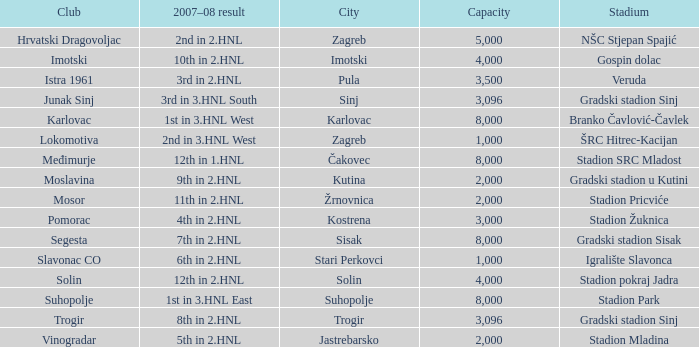What stadium has kutina as the city? Gradski stadion u Kutini. 